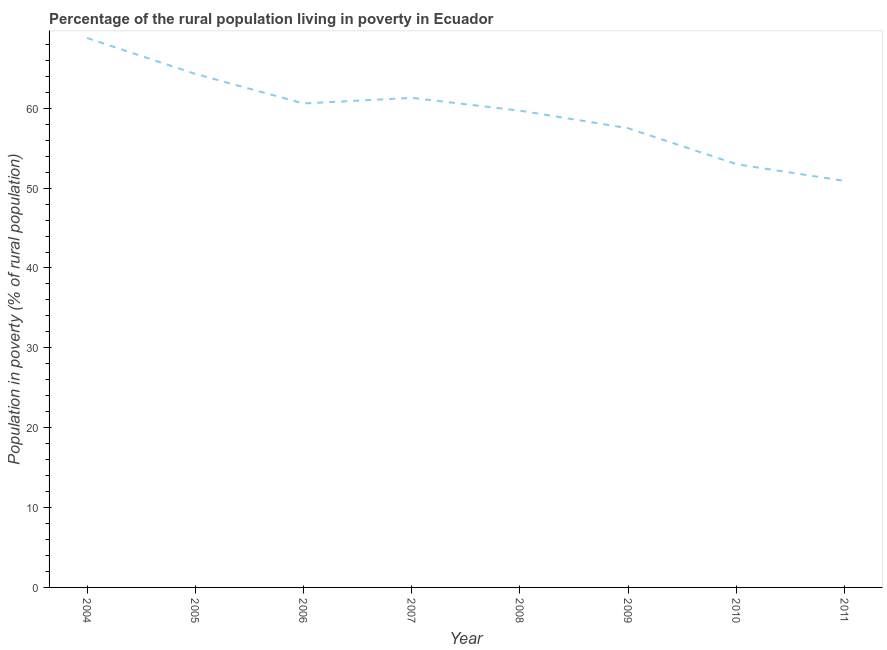What is the percentage of rural population living below poverty line in 2009?
Your answer should be compact. 57.5. Across all years, what is the maximum percentage of rural population living below poverty line?
Provide a succinct answer. 68.8. Across all years, what is the minimum percentage of rural population living below poverty line?
Provide a short and direct response. 50.9. In which year was the percentage of rural population living below poverty line minimum?
Make the answer very short. 2011. What is the sum of the percentage of rural population living below poverty line?
Make the answer very short. 476.1. What is the difference between the percentage of rural population living below poverty line in 2005 and 2011?
Your response must be concise. 13.4. What is the average percentage of rural population living below poverty line per year?
Provide a succinct answer. 59.51. What is the median percentage of rural population living below poverty line?
Offer a very short reply. 60.15. Do a majority of the years between 2007 and 2008 (inclusive) have percentage of rural population living below poverty line greater than 12 %?
Make the answer very short. Yes. What is the ratio of the percentage of rural population living below poverty line in 2009 to that in 2011?
Your answer should be compact. 1.13. Is the difference between the percentage of rural population living below poverty line in 2007 and 2008 greater than the difference between any two years?
Your answer should be compact. No. What is the difference between the highest and the second highest percentage of rural population living below poverty line?
Provide a short and direct response. 4.5. Is the sum of the percentage of rural population living below poverty line in 2006 and 2007 greater than the maximum percentage of rural population living below poverty line across all years?
Ensure brevity in your answer.  Yes. Does the percentage of rural population living below poverty line monotonically increase over the years?
Give a very brief answer. No. What is the difference between two consecutive major ticks on the Y-axis?
Offer a very short reply. 10. Are the values on the major ticks of Y-axis written in scientific E-notation?
Offer a terse response. No. Does the graph contain grids?
Your response must be concise. No. What is the title of the graph?
Provide a succinct answer. Percentage of the rural population living in poverty in Ecuador. What is the label or title of the X-axis?
Make the answer very short. Year. What is the label or title of the Y-axis?
Provide a succinct answer. Population in poverty (% of rural population). What is the Population in poverty (% of rural population) of 2004?
Provide a succinct answer. 68.8. What is the Population in poverty (% of rural population) in 2005?
Provide a succinct answer. 64.3. What is the Population in poverty (% of rural population) in 2006?
Your answer should be compact. 60.6. What is the Population in poverty (% of rural population) of 2007?
Your response must be concise. 61.3. What is the Population in poverty (% of rural population) in 2008?
Offer a very short reply. 59.7. What is the Population in poverty (% of rural population) in 2009?
Provide a short and direct response. 57.5. What is the Population in poverty (% of rural population) in 2010?
Provide a short and direct response. 53. What is the Population in poverty (% of rural population) in 2011?
Give a very brief answer. 50.9. What is the difference between the Population in poverty (% of rural population) in 2004 and 2006?
Your answer should be compact. 8.2. What is the difference between the Population in poverty (% of rural population) in 2004 and 2007?
Your answer should be compact. 7.5. What is the difference between the Population in poverty (% of rural population) in 2004 and 2008?
Ensure brevity in your answer.  9.1. What is the difference between the Population in poverty (% of rural population) in 2004 and 2009?
Give a very brief answer. 11.3. What is the difference between the Population in poverty (% of rural population) in 2004 and 2010?
Ensure brevity in your answer.  15.8. What is the difference between the Population in poverty (% of rural population) in 2004 and 2011?
Give a very brief answer. 17.9. What is the difference between the Population in poverty (% of rural population) in 2005 and 2006?
Provide a succinct answer. 3.7. What is the difference between the Population in poverty (% of rural population) in 2005 and 2008?
Offer a terse response. 4.6. What is the difference between the Population in poverty (% of rural population) in 2005 and 2009?
Offer a very short reply. 6.8. What is the difference between the Population in poverty (% of rural population) in 2005 and 2010?
Provide a succinct answer. 11.3. What is the difference between the Population in poverty (% of rural population) in 2006 and 2008?
Give a very brief answer. 0.9. What is the difference between the Population in poverty (% of rural population) in 2006 and 2010?
Your answer should be very brief. 7.6. What is the difference between the Population in poverty (% of rural population) in 2007 and 2008?
Keep it short and to the point. 1.6. What is the difference between the Population in poverty (% of rural population) in 2007 and 2011?
Offer a terse response. 10.4. What is the difference between the Population in poverty (% of rural population) in 2008 and 2009?
Your answer should be compact. 2.2. What is the difference between the Population in poverty (% of rural population) in 2009 and 2010?
Provide a short and direct response. 4.5. What is the difference between the Population in poverty (% of rural population) in 2010 and 2011?
Offer a terse response. 2.1. What is the ratio of the Population in poverty (% of rural population) in 2004 to that in 2005?
Your answer should be compact. 1.07. What is the ratio of the Population in poverty (% of rural population) in 2004 to that in 2006?
Ensure brevity in your answer.  1.14. What is the ratio of the Population in poverty (% of rural population) in 2004 to that in 2007?
Your answer should be very brief. 1.12. What is the ratio of the Population in poverty (% of rural population) in 2004 to that in 2008?
Your answer should be very brief. 1.15. What is the ratio of the Population in poverty (% of rural population) in 2004 to that in 2009?
Make the answer very short. 1.2. What is the ratio of the Population in poverty (% of rural population) in 2004 to that in 2010?
Your answer should be very brief. 1.3. What is the ratio of the Population in poverty (% of rural population) in 2004 to that in 2011?
Your response must be concise. 1.35. What is the ratio of the Population in poverty (% of rural population) in 2005 to that in 2006?
Provide a succinct answer. 1.06. What is the ratio of the Population in poverty (% of rural population) in 2005 to that in 2007?
Your response must be concise. 1.05. What is the ratio of the Population in poverty (% of rural population) in 2005 to that in 2008?
Make the answer very short. 1.08. What is the ratio of the Population in poverty (% of rural population) in 2005 to that in 2009?
Ensure brevity in your answer.  1.12. What is the ratio of the Population in poverty (% of rural population) in 2005 to that in 2010?
Offer a terse response. 1.21. What is the ratio of the Population in poverty (% of rural population) in 2005 to that in 2011?
Offer a very short reply. 1.26. What is the ratio of the Population in poverty (% of rural population) in 2006 to that in 2009?
Your response must be concise. 1.05. What is the ratio of the Population in poverty (% of rural population) in 2006 to that in 2010?
Your response must be concise. 1.14. What is the ratio of the Population in poverty (% of rural population) in 2006 to that in 2011?
Make the answer very short. 1.19. What is the ratio of the Population in poverty (% of rural population) in 2007 to that in 2009?
Provide a short and direct response. 1.07. What is the ratio of the Population in poverty (% of rural population) in 2007 to that in 2010?
Offer a very short reply. 1.16. What is the ratio of the Population in poverty (% of rural population) in 2007 to that in 2011?
Your answer should be very brief. 1.2. What is the ratio of the Population in poverty (% of rural population) in 2008 to that in 2009?
Offer a terse response. 1.04. What is the ratio of the Population in poverty (% of rural population) in 2008 to that in 2010?
Provide a succinct answer. 1.13. What is the ratio of the Population in poverty (% of rural population) in 2008 to that in 2011?
Provide a short and direct response. 1.17. What is the ratio of the Population in poverty (% of rural population) in 2009 to that in 2010?
Offer a terse response. 1.08. What is the ratio of the Population in poverty (% of rural population) in 2009 to that in 2011?
Offer a terse response. 1.13. What is the ratio of the Population in poverty (% of rural population) in 2010 to that in 2011?
Provide a succinct answer. 1.04. 